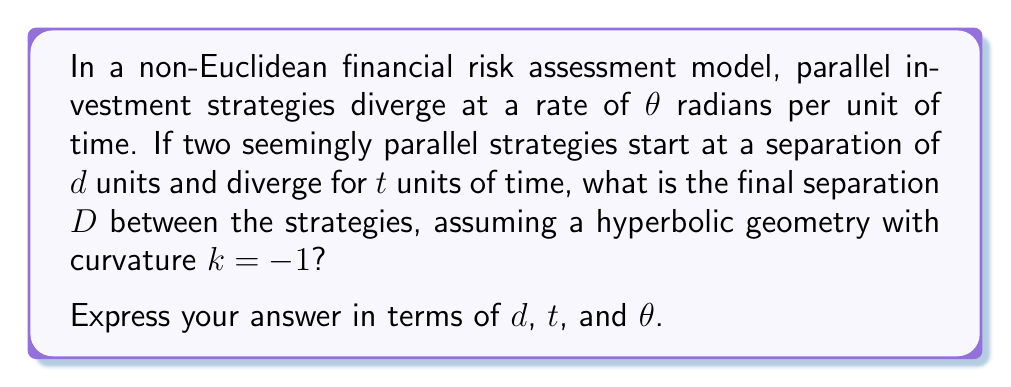Provide a solution to this math problem. To solve this problem, we'll use concepts from hyperbolic geometry, which is a type of non-Euclidean geometry where the parallel postulate is violated. In this context, parallel lines diverge.

Step 1: Understand the hyperbolic distance formula
In hyperbolic geometry with curvature $k=-1$, the distance $D$ between two points that started at a distance $d$ and diverged at an angle $\theta$ for a time $t$ is given by:

$$D = \operatorname{arcosh}(\cosh d \cosh t - \sinh d \sinh t \cos \theta)$$

Where $\operatorname{arcosh}$ is the inverse hyperbolic cosine function.

Step 2: Simplify the formula for parallel lines
For initially parallel lines, the angle $\theta$ represents the rate of divergence per unit time. The total divergence angle after time $t$ is $\theta t$. Substituting this into our formula:

$$D = \operatorname{arcosh}(\cosh d \cosh t - \sinh d \sinh t \cos (\theta t))$$

Step 3: Note that this formula directly gives us the final separation $D$ in terms of $d$, $t$, and $\theta$, which is what the question asks for.

This formula encapsulates how parallel investment strategies in this non-Euclidean risk model diverge over time, potentially leading to significantly different outcomes than what would be expected in a Euclidean model where parallel strategies remain equidistant.
Answer: $D = \operatorname{arcosh}(\cosh d \cosh t - \sinh d \sinh t \cos (\theta t))$ 